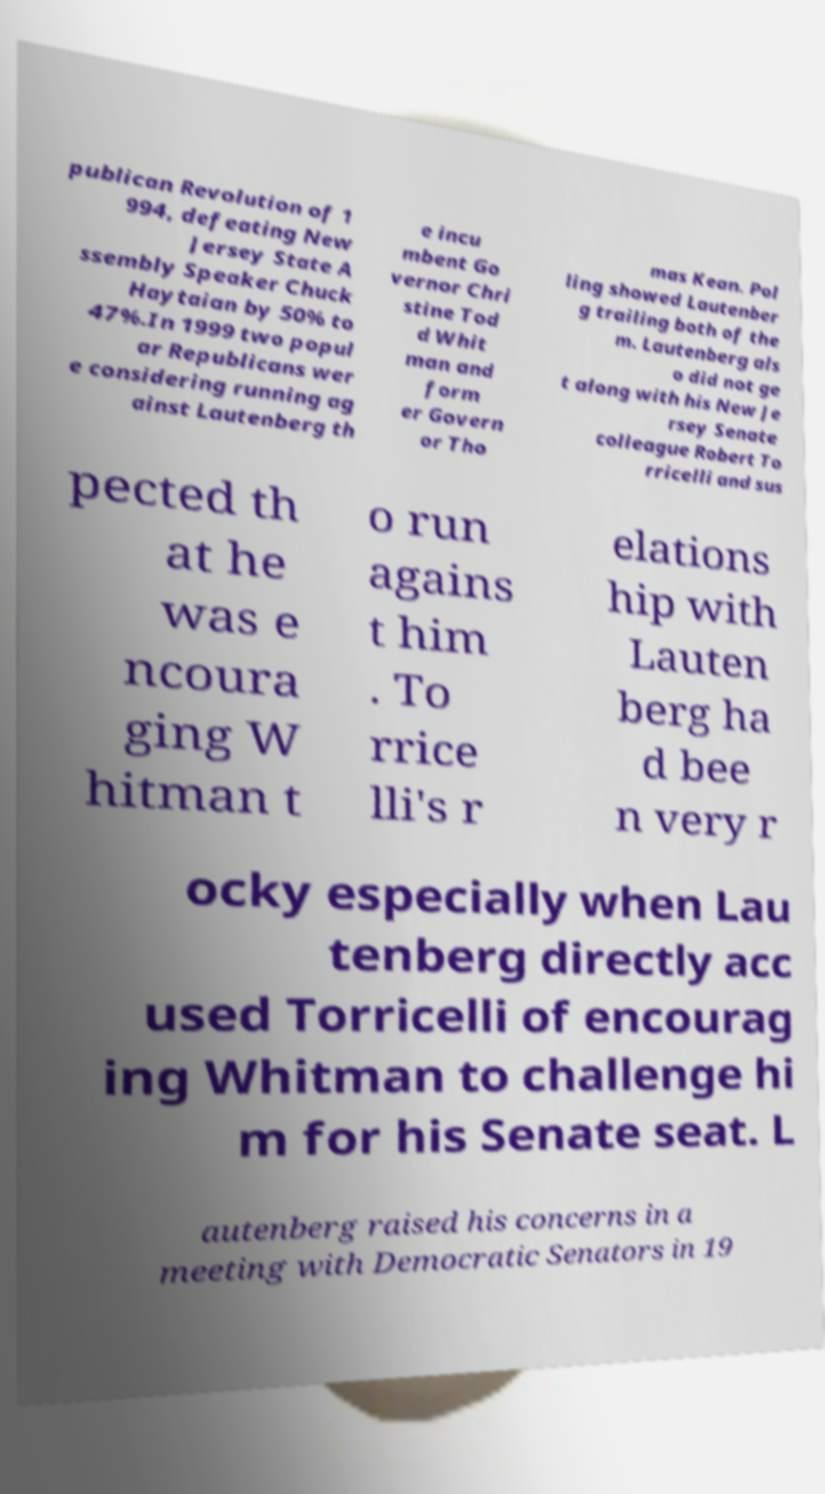Could you extract and type out the text from this image? publican Revolution of 1 994, defeating New Jersey State A ssembly Speaker Chuck Haytaian by 50% to 47%.In 1999 two popul ar Republicans wer e considering running ag ainst Lautenberg th e incu mbent Go vernor Chri stine Tod d Whit man and form er Govern or Tho mas Kean. Pol ling showed Lautenber g trailing both of the m. Lautenberg als o did not ge t along with his New Je rsey Senate colleague Robert To rricelli and sus pected th at he was e ncoura ging W hitman t o run agains t him . To rrice lli's r elations hip with Lauten berg ha d bee n very r ocky especially when Lau tenberg directly acc used Torricelli of encourag ing Whitman to challenge hi m for his Senate seat. L autenberg raised his concerns in a meeting with Democratic Senators in 19 